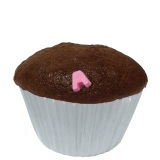What is that? This is a cupcake, likely a chocolate one, topped with a small pink decoration or piece of fondant. 